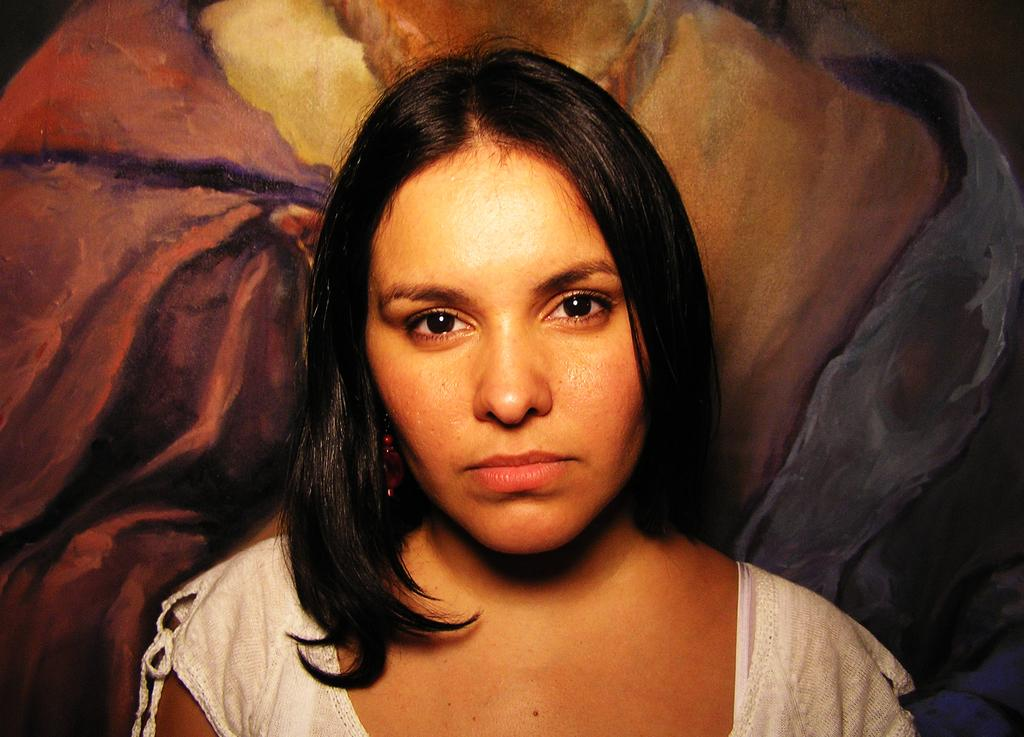Who is present in the image? There is a woman in the image. What can be seen behind the woman? There is a painting behind the woman in the image. What type of thread is being used to create the painting in the image? There is no thread present in the image; it is a painting, not a textile or fabric. 